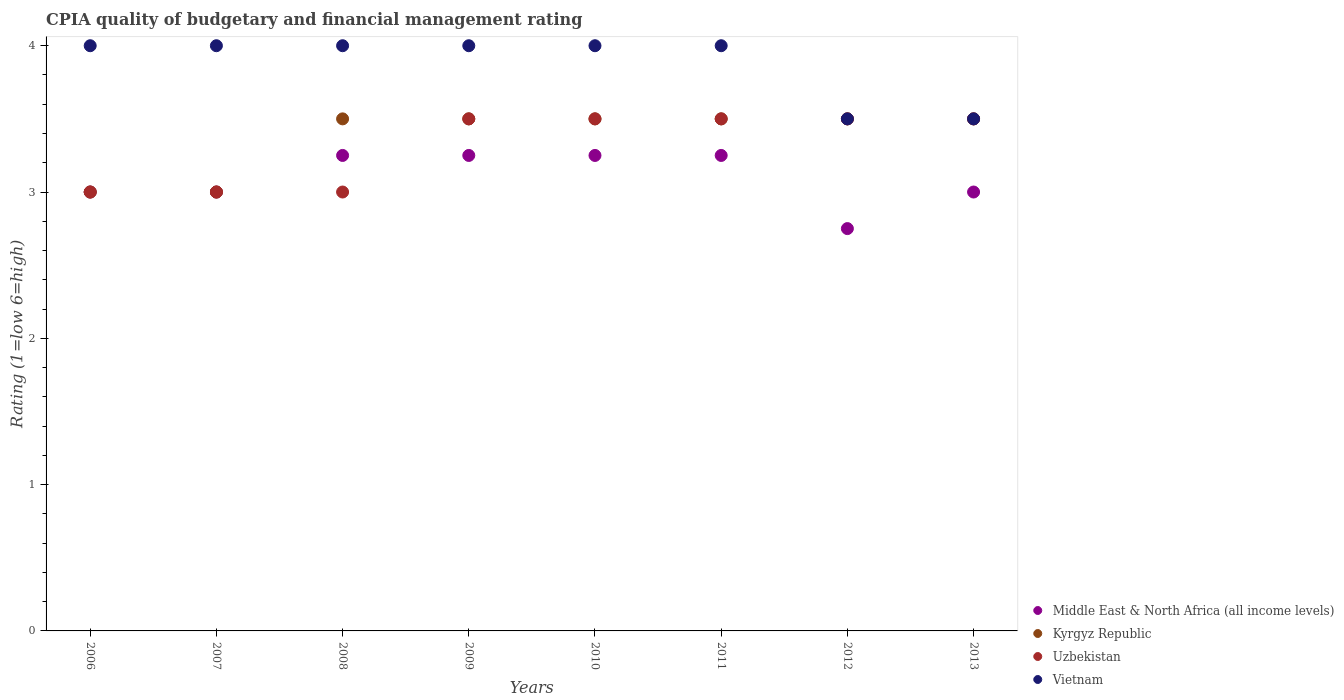How many different coloured dotlines are there?
Offer a very short reply. 4. What is the CPIA rating in Kyrgyz Republic in 2006?
Provide a succinct answer. 3. Across all years, what is the maximum CPIA rating in Middle East & North Africa (all income levels)?
Offer a very short reply. 3.25. In which year was the CPIA rating in Uzbekistan minimum?
Offer a very short reply. 2006. What is the total CPIA rating in Middle East & North Africa (all income levels) in the graph?
Ensure brevity in your answer.  24.75. What is the average CPIA rating in Uzbekistan per year?
Your response must be concise. 3.31. In the year 2008, what is the difference between the CPIA rating in Vietnam and CPIA rating in Kyrgyz Republic?
Ensure brevity in your answer.  0.5. In how many years, is the CPIA rating in Uzbekistan greater than 2.4?
Keep it short and to the point. 8. Is the CPIA rating in Vietnam in 2011 less than that in 2013?
Your answer should be very brief. No. What is the difference between the highest and the second highest CPIA rating in Uzbekistan?
Offer a very short reply. 0. What is the difference between the highest and the lowest CPIA rating in Uzbekistan?
Provide a succinct answer. 0.5. Is it the case that in every year, the sum of the CPIA rating in Kyrgyz Republic and CPIA rating in Uzbekistan  is greater than the CPIA rating in Middle East & North Africa (all income levels)?
Offer a terse response. Yes. Does the CPIA rating in Middle East & North Africa (all income levels) monotonically increase over the years?
Your answer should be very brief. No. How many years are there in the graph?
Offer a terse response. 8. What is the difference between two consecutive major ticks on the Y-axis?
Ensure brevity in your answer.  1. Are the values on the major ticks of Y-axis written in scientific E-notation?
Provide a succinct answer. No. Does the graph contain any zero values?
Your answer should be compact. No. Where does the legend appear in the graph?
Give a very brief answer. Bottom right. What is the title of the graph?
Provide a short and direct response. CPIA quality of budgetary and financial management rating. Does "India" appear as one of the legend labels in the graph?
Offer a terse response. No. What is the label or title of the X-axis?
Offer a terse response. Years. What is the label or title of the Y-axis?
Provide a succinct answer. Rating (1=low 6=high). What is the Rating (1=low 6=high) in Kyrgyz Republic in 2006?
Offer a very short reply. 3. What is the Rating (1=low 6=high) in Uzbekistan in 2006?
Give a very brief answer. 3. What is the Rating (1=low 6=high) of Kyrgyz Republic in 2007?
Your answer should be compact. 3. What is the Rating (1=low 6=high) of Vietnam in 2007?
Provide a short and direct response. 4. What is the Rating (1=low 6=high) of Middle East & North Africa (all income levels) in 2008?
Ensure brevity in your answer.  3.25. What is the Rating (1=low 6=high) in Uzbekistan in 2008?
Offer a very short reply. 3. What is the Rating (1=low 6=high) in Uzbekistan in 2009?
Your answer should be very brief. 3.5. What is the Rating (1=low 6=high) of Middle East & North Africa (all income levels) in 2010?
Offer a terse response. 3.25. What is the Rating (1=low 6=high) in Uzbekistan in 2010?
Ensure brevity in your answer.  3.5. What is the Rating (1=low 6=high) in Middle East & North Africa (all income levels) in 2011?
Your answer should be very brief. 3.25. What is the Rating (1=low 6=high) in Middle East & North Africa (all income levels) in 2012?
Provide a short and direct response. 2.75. What is the Rating (1=low 6=high) in Uzbekistan in 2012?
Your answer should be very brief. 3.5. What is the Rating (1=low 6=high) in Vietnam in 2012?
Your answer should be very brief. 3.5. What is the Rating (1=low 6=high) in Kyrgyz Republic in 2013?
Your answer should be compact. 3.5. What is the Rating (1=low 6=high) in Uzbekistan in 2013?
Keep it short and to the point. 3.5. Across all years, what is the maximum Rating (1=low 6=high) of Middle East & North Africa (all income levels)?
Make the answer very short. 3.25. Across all years, what is the minimum Rating (1=low 6=high) in Middle East & North Africa (all income levels)?
Keep it short and to the point. 2.75. Across all years, what is the minimum Rating (1=low 6=high) of Kyrgyz Republic?
Your answer should be compact. 3. What is the total Rating (1=low 6=high) of Middle East & North Africa (all income levels) in the graph?
Provide a succinct answer. 24.75. What is the total Rating (1=low 6=high) of Uzbekistan in the graph?
Provide a short and direct response. 26.5. What is the difference between the Rating (1=low 6=high) in Middle East & North Africa (all income levels) in 2006 and that in 2007?
Ensure brevity in your answer.  0. What is the difference between the Rating (1=low 6=high) in Kyrgyz Republic in 2006 and that in 2007?
Your response must be concise. 0. What is the difference between the Rating (1=low 6=high) in Uzbekistan in 2006 and that in 2007?
Your answer should be compact. 0. What is the difference between the Rating (1=low 6=high) of Kyrgyz Republic in 2006 and that in 2008?
Offer a very short reply. -0.5. What is the difference between the Rating (1=low 6=high) of Vietnam in 2006 and that in 2008?
Offer a very short reply. 0. What is the difference between the Rating (1=low 6=high) of Uzbekistan in 2006 and that in 2009?
Keep it short and to the point. -0.5. What is the difference between the Rating (1=low 6=high) of Vietnam in 2006 and that in 2009?
Your answer should be compact. 0. What is the difference between the Rating (1=low 6=high) of Middle East & North Africa (all income levels) in 2006 and that in 2010?
Give a very brief answer. -0.25. What is the difference between the Rating (1=low 6=high) of Kyrgyz Republic in 2006 and that in 2010?
Offer a terse response. -0.5. What is the difference between the Rating (1=low 6=high) of Uzbekistan in 2006 and that in 2010?
Offer a very short reply. -0.5. What is the difference between the Rating (1=low 6=high) in Kyrgyz Republic in 2006 and that in 2011?
Keep it short and to the point. -0.5. What is the difference between the Rating (1=low 6=high) in Uzbekistan in 2006 and that in 2011?
Offer a terse response. -0.5. What is the difference between the Rating (1=low 6=high) in Vietnam in 2006 and that in 2011?
Keep it short and to the point. 0. What is the difference between the Rating (1=low 6=high) of Middle East & North Africa (all income levels) in 2006 and that in 2012?
Your answer should be very brief. 0.25. What is the difference between the Rating (1=low 6=high) of Kyrgyz Republic in 2006 and that in 2012?
Your answer should be compact. -0.5. What is the difference between the Rating (1=low 6=high) of Vietnam in 2006 and that in 2012?
Offer a very short reply. 0.5. What is the difference between the Rating (1=low 6=high) in Middle East & North Africa (all income levels) in 2006 and that in 2013?
Ensure brevity in your answer.  0. What is the difference between the Rating (1=low 6=high) in Kyrgyz Republic in 2006 and that in 2013?
Your response must be concise. -0.5. What is the difference between the Rating (1=low 6=high) in Uzbekistan in 2006 and that in 2013?
Offer a very short reply. -0.5. What is the difference between the Rating (1=low 6=high) in Vietnam in 2006 and that in 2013?
Keep it short and to the point. 0.5. What is the difference between the Rating (1=low 6=high) in Middle East & North Africa (all income levels) in 2007 and that in 2008?
Your response must be concise. -0.25. What is the difference between the Rating (1=low 6=high) in Kyrgyz Republic in 2007 and that in 2008?
Offer a terse response. -0.5. What is the difference between the Rating (1=low 6=high) in Middle East & North Africa (all income levels) in 2007 and that in 2009?
Provide a short and direct response. -0.25. What is the difference between the Rating (1=low 6=high) of Kyrgyz Republic in 2007 and that in 2009?
Keep it short and to the point. -0.5. What is the difference between the Rating (1=low 6=high) in Uzbekistan in 2007 and that in 2010?
Provide a short and direct response. -0.5. What is the difference between the Rating (1=low 6=high) of Kyrgyz Republic in 2007 and that in 2011?
Ensure brevity in your answer.  -0.5. What is the difference between the Rating (1=low 6=high) of Vietnam in 2007 and that in 2011?
Offer a very short reply. 0. What is the difference between the Rating (1=low 6=high) in Middle East & North Africa (all income levels) in 2007 and that in 2013?
Your response must be concise. 0. What is the difference between the Rating (1=low 6=high) in Kyrgyz Republic in 2007 and that in 2013?
Your answer should be very brief. -0.5. What is the difference between the Rating (1=low 6=high) in Vietnam in 2007 and that in 2013?
Provide a short and direct response. 0.5. What is the difference between the Rating (1=low 6=high) in Middle East & North Africa (all income levels) in 2008 and that in 2009?
Provide a short and direct response. 0. What is the difference between the Rating (1=low 6=high) of Vietnam in 2008 and that in 2009?
Ensure brevity in your answer.  0. What is the difference between the Rating (1=low 6=high) of Kyrgyz Republic in 2008 and that in 2010?
Offer a very short reply. 0. What is the difference between the Rating (1=low 6=high) of Vietnam in 2008 and that in 2010?
Offer a very short reply. 0. What is the difference between the Rating (1=low 6=high) of Middle East & North Africa (all income levels) in 2008 and that in 2011?
Make the answer very short. 0. What is the difference between the Rating (1=low 6=high) in Kyrgyz Republic in 2008 and that in 2011?
Provide a succinct answer. 0. What is the difference between the Rating (1=low 6=high) in Uzbekistan in 2008 and that in 2011?
Give a very brief answer. -0.5. What is the difference between the Rating (1=low 6=high) in Kyrgyz Republic in 2008 and that in 2012?
Keep it short and to the point. 0. What is the difference between the Rating (1=low 6=high) in Kyrgyz Republic in 2008 and that in 2013?
Offer a terse response. 0. What is the difference between the Rating (1=low 6=high) in Kyrgyz Republic in 2009 and that in 2010?
Make the answer very short. 0. What is the difference between the Rating (1=low 6=high) in Vietnam in 2009 and that in 2010?
Ensure brevity in your answer.  0. What is the difference between the Rating (1=low 6=high) in Kyrgyz Republic in 2009 and that in 2011?
Give a very brief answer. 0. What is the difference between the Rating (1=low 6=high) of Kyrgyz Republic in 2009 and that in 2012?
Provide a succinct answer. 0. What is the difference between the Rating (1=low 6=high) in Uzbekistan in 2009 and that in 2012?
Keep it short and to the point. 0. What is the difference between the Rating (1=low 6=high) in Middle East & North Africa (all income levels) in 2009 and that in 2013?
Offer a terse response. 0.25. What is the difference between the Rating (1=low 6=high) of Uzbekistan in 2010 and that in 2011?
Offer a very short reply. 0. What is the difference between the Rating (1=low 6=high) in Vietnam in 2010 and that in 2011?
Ensure brevity in your answer.  0. What is the difference between the Rating (1=low 6=high) of Middle East & North Africa (all income levels) in 2010 and that in 2012?
Provide a short and direct response. 0.5. What is the difference between the Rating (1=low 6=high) in Kyrgyz Republic in 2010 and that in 2012?
Give a very brief answer. 0. What is the difference between the Rating (1=low 6=high) of Uzbekistan in 2010 and that in 2012?
Give a very brief answer. 0. What is the difference between the Rating (1=low 6=high) in Vietnam in 2010 and that in 2012?
Offer a very short reply. 0.5. What is the difference between the Rating (1=low 6=high) in Kyrgyz Republic in 2010 and that in 2013?
Your answer should be compact. 0. What is the difference between the Rating (1=low 6=high) in Middle East & North Africa (all income levels) in 2011 and that in 2012?
Offer a terse response. 0.5. What is the difference between the Rating (1=low 6=high) in Uzbekistan in 2011 and that in 2012?
Provide a short and direct response. 0. What is the difference between the Rating (1=low 6=high) in Vietnam in 2011 and that in 2012?
Your answer should be very brief. 0.5. What is the difference between the Rating (1=low 6=high) of Middle East & North Africa (all income levels) in 2011 and that in 2013?
Keep it short and to the point. 0.25. What is the difference between the Rating (1=low 6=high) of Kyrgyz Republic in 2011 and that in 2013?
Make the answer very short. 0. What is the difference between the Rating (1=low 6=high) in Kyrgyz Republic in 2012 and that in 2013?
Your response must be concise. 0. What is the difference between the Rating (1=low 6=high) of Middle East & North Africa (all income levels) in 2006 and the Rating (1=low 6=high) of Kyrgyz Republic in 2007?
Your answer should be compact. 0. What is the difference between the Rating (1=low 6=high) of Kyrgyz Republic in 2006 and the Rating (1=low 6=high) of Uzbekistan in 2007?
Offer a terse response. 0. What is the difference between the Rating (1=low 6=high) in Middle East & North Africa (all income levels) in 2006 and the Rating (1=low 6=high) in Kyrgyz Republic in 2008?
Offer a terse response. -0.5. What is the difference between the Rating (1=low 6=high) of Kyrgyz Republic in 2006 and the Rating (1=low 6=high) of Vietnam in 2008?
Keep it short and to the point. -1. What is the difference between the Rating (1=low 6=high) of Middle East & North Africa (all income levels) in 2006 and the Rating (1=low 6=high) of Uzbekistan in 2009?
Offer a very short reply. -0.5. What is the difference between the Rating (1=low 6=high) of Middle East & North Africa (all income levels) in 2006 and the Rating (1=low 6=high) of Vietnam in 2009?
Provide a short and direct response. -1. What is the difference between the Rating (1=low 6=high) in Kyrgyz Republic in 2006 and the Rating (1=low 6=high) in Uzbekistan in 2009?
Provide a succinct answer. -0.5. What is the difference between the Rating (1=low 6=high) of Middle East & North Africa (all income levels) in 2006 and the Rating (1=low 6=high) of Kyrgyz Republic in 2010?
Give a very brief answer. -0.5. What is the difference between the Rating (1=low 6=high) of Middle East & North Africa (all income levels) in 2006 and the Rating (1=low 6=high) of Vietnam in 2010?
Your response must be concise. -1. What is the difference between the Rating (1=low 6=high) in Kyrgyz Republic in 2006 and the Rating (1=low 6=high) in Vietnam in 2010?
Provide a succinct answer. -1. What is the difference between the Rating (1=low 6=high) of Middle East & North Africa (all income levels) in 2006 and the Rating (1=low 6=high) of Kyrgyz Republic in 2011?
Offer a terse response. -0.5. What is the difference between the Rating (1=low 6=high) of Middle East & North Africa (all income levels) in 2006 and the Rating (1=low 6=high) of Uzbekistan in 2011?
Your answer should be compact. -0.5. What is the difference between the Rating (1=low 6=high) in Kyrgyz Republic in 2006 and the Rating (1=low 6=high) in Uzbekistan in 2011?
Your answer should be compact. -0.5. What is the difference between the Rating (1=low 6=high) in Kyrgyz Republic in 2006 and the Rating (1=low 6=high) in Vietnam in 2011?
Provide a succinct answer. -1. What is the difference between the Rating (1=low 6=high) in Middle East & North Africa (all income levels) in 2006 and the Rating (1=low 6=high) in Kyrgyz Republic in 2012?
Offer a terse response. -0.5. What is the difference between the Rating (1=low 6=high) in Middle East & North Africa (all income levels) in 2006 and the Rating (1=low 6=high) in Vietnam in 2012?
Ensure brevity in your answer.  -0.5. What is the difference between the Rating (1=low 6=high) of Middle East & North Africa (all income levels) in 2006 and the Rating (1=low 6=high) of Uzbekistan in 2013?
Give a very brief answer. -0.5. What is the difference between the Rating (1=low 6=high) of Middle East & North Africa (all income levels) in 2006 and the Rating (1=low 6=high) of Vietnam in 2013?
Your answer should be compact. -0.5. What is the difference between the Rating (1=low 6=high) of Kyrgyz Republic in 2006 and the Rating (1=low 6=high) of Vietnam in 2013?
Your response must be concise. -0.5. What is the difference between the Rating (1=low 6=high) in Middle East & North Africa (all income levels) in 2007 and the Rating (1=low 6=high) in Kyrgyz Republic in 2008?
Your answer should be very brief. -0.5. What is the difference between the Rating (1=low 6=high) in Middle East & North Africa (all income levels) in 2007 and the Rating (1=low 6=high) in Uzbekistan in 2008?
Make the answer very short. 0. What is the difference between the Rating (1=low 6=high) of Middle East & North Africa (all income levels) in 2007 and the Rating (1=low 6=high) of Kyrgyz Republic in 2009?
Offer a very short reply. -0.5. What is the difference between the Rating (1=low 6=high) in Middle East & North Africa (all income levels) in 2007 and the Rating (1=low 6=high) in Uzbekistan in 2009?
Give a very brief answer. -0.5. What is the difference between the Rating (1=low 6=high) in Middle East & North Africa (all income levels) in 2007 and the Rating (1=low 6=high) in Vietnam in 2010?
Your answer should be very brief. -1. What is the difference between the Rating (1=low 6=high) of Kyrgyz Republic in 2007 and the Rating (1=low 6=high) of Uzbekistan in 2010?
Give a very brief answer. -0.5. What is the difference between the Rating (1=low 6=high) in Middle East & North Africa (all income levels) in 2007 and the Rating (1=low 6=high) in Kyrgyz Republic in 2011?
Make the answer very short. -0.5. What is the difference between the Rating (1=low 6=high) of Middle East & North Africa (all income levels) in 2007 and the Rating (1=low 6=high) of Uzbekistan in 2012?
Your response must be concise. -0.5. What is the difference between the Rating (1=low 6=high) of Uzbekistan in 2007 and the Rating (1=low 6=high) of Vietnam in 2012?
Provide a short and direct response. -0.5. What is the difference between the Rating (1=low 6=high) of Middle East & North Africa (all income levels) in 2007 and the Rating (1=low 6=high) of Kyrgyz Republic in 2013?
Make the answer very short. -0.5. What is the difference between the Rating (1=low 6=high) of Middle East & North Africa (all income levels) in 2007 and the Rating (1=low 6=high) of Uzbekistan in 2013?
Ensure brevity in your answer.  -0.5. What is the difference between the Rating (1=low 6=high) of Kyrgyz Republic in 2007 and the Rating (1=low 6=high) of Uzbekistan in 2013?
Give a very brief answer. -0.5. What is the difference between the Rating (1=low 6=high) in Uzbekistan in 2007 and the Rating (1=low 6=high) in Vietnam in 2013?
Offer a very short reply. -0.5. What is the difference between the Rating (1=low 6=high) of Middle East & North Africa (all income levels) in 2008 and the Rating (1=low 6=high) of Kyrgyz Republic in 2009?
Make the answer very short. -0.25. What is the difference between the Rating (1=low 6=high) in Middle East & North Africa (all income levels) in 2008 and the Rating (1=low 6=high) in Uzbekistan in 2009?
Your response must be concise. -0.25. What is the difference between the Rating (1=low 6=high) in Middle East & North Africa (all income levels) in 2008 and the Rating (1=low 6=high) in Vietnam in 2009?
Make the answer very short. -0.75. What is the difference between the Rating (1=low 6=high) in Kyrgyz Republic in 2008 and the Rating (1=low 6=high) in Uzbekistan in 2009?
Make the answer very short. 0. What is the difference between the Rating (1=low 6=high) in Kyrgyz Republic in 2008 and the Rating (1=low 6=high) in Vietnam in 2009?
Your answer should be compact. -0.5. What is the difference between the Rating (1=low 6=high) of Uzbekistan in 2008 and the Rating (1=low 6=high) of Vietnam in 2009?
Provide a succinct answer. -1. What is the difference between the Rating (1=low 6=high) of Middle East & North Africa (all income levels) in 2008 and the Rating (1=low 6=high) of Kyrgyz Republic in 2010?
Provide a succinct answer. -0.25. What is the difference between the Rating (1=low 6=high) of Middle East & North Africa (all income levels) in 2008 and the Rating (1=low 6=high) of Uzbekistan in 2010?
Your answer should be very brief. -0.25. What is the difference between the Rating (1=low 6=high) in Middle East & North Africa (all income levels) in 2008 and the Rating (1=low 6=high) in Vietnam in 2010?
Give a very brief answer. -0.75. What is the difference between the Rating (1=low 6=high) of Kyrgyz Republic in 2008 and the Rating (1=low 6=high) of Vietnam in 2010?
Offer a very short reply. -0.5. What is the difference between the Rating (1=low 6=high) of Middle East & North Africa (all income levels) in 2008 and the Rating (1=low 6=high) of Uzbekistan in 2011?
Make the answer very short. -0.25. What is the difference between the Rating (1=low 6=high) in Middle East & North Africa (all income levels) in 2008 and the Rating (1=low 6=high) in Vietnam in 2011?
Offer a terse response. -0.75. What is the difference between the Rating (1=low 6=high) of Kyrgyz Republic in 2008 and the Rating (1=low 6=high) of Uzbekistan in 2011?
Keep it short and to the point. 0. What is the difference between the Rating (1=low 6=high) in Uzbekistan in 2008 and the Rating (1=low 6=high) in Vietnam in 2011?
Make the answer very short. -1. What is the difference between the Rating (1=low 6=high) of Middle East & North Africa (all income levels) in 2008 and the Rating (1=low 6=high) of Vietnam in 2012?
Make the answer very short. -0.25. What is the difference between the Rating (1=low 6=high) of Kyrgyz Republic in 2008 and the Rating (1=low 6=high) of Uzbekistan in 2012?
Make the answer very short. 0. What is the difference between the Rating (1=low 6=high) in Kyrgyz Republic in 2008 and the Rating (1=low 6=high) in Vietnam in 2012?
Make the answer very short. 0. What is the difference between the Rating (1=low 6=high) in Middle East & North Africa (all income levels) in 2008 and the Rating (1=low 6=high) in Uzbekistan in 2013?
Your answer should be compact. -0.25. What is the difference between the Rating (1=low 6=high) in Middle East & North Africa (all income levels) in 2008 and the Rating (1=low 6=high) in Vietnam in 2013?
Ensure brevity in your answer.  -0.25. What is the difference between the Rating (1=low 6=high) in Kyrgyz Republic in 2008 and the Rating (1=low 6=high) in Uzbekistan in 2013?
Keep it short and to the point. 0. What is the difference between the Rating (1=low 6=high) in Kyrgyz Republic in 2008 and the Rating (1=low 6=high) in Vietnam in 2013?
Offer a terse response. 0. What is the difference between the Rating (1=low 6=high) in Uzbekistan in 2008 and the Rating (1=low 6=high) in Vietnam in 2013?
Your response must be concise. -0.5. What is the difference between the Rating (1=low 6=high) of Middle East & North Africa (all income levels) in 2009 and the Rating (1=low 6=high) of Kyrgyz Republic in 2010?
Offer a terse response. -0.25. What is the difference between the Rating (1=low 6=high) of Middle East & North Africa (all income levels) in 2009 and the Rating (1=low 6=high) of Vietnam in 2010?
Give a very brief answer. -0.75. What is the difference between the Rating (1=low 6=high) in Kyrgyz Republic in 2009 and the Rating (1=low 6=high) in Vietnam in 2010?
Offer a very short reply. -0.5. What is the difference between the Rating (1=low 6=high) in Uzbekistan in 2009 and the Rating (1=low 6=high) in Vietnam in 2010?
Your answer should be very brief. -0.5. What is the difference between the Rating (1=low 6=high) in Middle East & North Africa (all income levels) in 2009 and the Rating (1=low 6=high) in Vietnam in 2011?
Your answer should be very brief. -0.75. What is the difference between the Rating (1=low 6=high) in Kyrgyz Republic in 2009 and the Rating (1=low 6=high) in Vietnam in 2011?
Your answer should be very brief. -0.5. What is the difference between the Rating (1=low 6=high) of Uzbekistan in 2009 and the Rating (1=low 6=high) of Vietnam in 2011?
Your answer should be very brief. -0.5. What is the difference between the Rating (1=low 6=high) of Middle East & North Africa (all income levels) in 2009 and the Rating (1=low 6=high) of Uzbekistan in 2012?
Make the answer very short. -0.25. What is the difference between the Rating (1=low 6=high) of Middle East & North Africa (all income levels) in 2009 and the Rating (1=low 6=high) of Vietnam in 2012?
Your response must be concise. -0.25. What is the difference between the Rating (1=low 6=high) of Kyrgyz Republic in 2009 and the Rating (1=low 6=high) of Uzbekistan in 2012?
Provide a succinct answer. 0. What is the difference between the Rating (1=low 6=high) in Kyrgyz Republic in 2009 and the Rating (1=low 6=high) in Vietnam in 2012?
Provide a short and direct response. 0. What is the difference between the Rating (1=low 6=high) in Middle East & North Africa (all income levels) in 2009 and the Rating (1=low 6=high) in Kyrgyz Republic in 2013?
Offer a very short reply. -0.25. What is the difference between the Rating (1=low 6=high) in Middle East & North Africa (all income levels) in 2009 and the Rating (1=low 6=high) in Vietnam in 2013?
Your answer should be very brief. -0.25. What is the difference between the Rating (1=low 6=high) in Kyrgyz Republic in 2009 and the Rating (1=low 6=high) in Vietnam in 2013?
Keep it short and to the point. 0. What is the difference between the Rating (1=low 6=high) in Middle East & North Africa (all income levels) in 2010 and the Rating (1=low 6=high) in Uzbekistan in 2011?
Give a very brief answer. -0.25. What is the difference between the Rating (1=low 6=high) in Middle East & North Africa (all income levels) in 2010 and the Rating (1=low 6=high) in Vietnam in 2011?
Make the answer very short. -0.75. What is the difference between the Rating (1=low 6=high) in Kyrgyz Republic in 2010 and the Rating (1=low 6=high) in Uzbekistan in 2011?
Provide a short and direct response. 0. What is the difference between the Rating (1=low 6=high) in Middle East & North Africa (all income levels) in 2010 and the Rating (1=low 6=high) in Uzbekistan in 2012?
Give a very brief answer. -0.25. What is the difference between the Rating (1=low 6=high) of Kyrgyz Republic in 2010 and the Rating (1=low 6=high) of Uzbekistan in 2012?
Ensure brevity in your answer.  0. What is the difference between the Rating (1=low 6=high) in Kyrgyz Republic in 2010 and the Rating (1=low 6=high) in Vietnam in 2012?
Keep it short and to the point. 0. What is the difference between the Rating (1=low 6=high) of Middle East & North Africa (all income levels) in 2010 and the Rating (1=low 6=high) of Kyrgyz Republic in 2013?
Offer a very short reply. -0.25. What is the difference between the Rating (1=low 6=high) in Middle East & North Africa (all income levels) in 2010 and the Rating (1=low 6=high) in Vietnam in 2013?
Ensure brevity in your answer.  -0.25. What is the difference between the Rating (1=low 6=high) in Kyrgyz Republic in 2010 and the Rating (1=low 6=high) in Uzbekistan in 2013?
Provide a succinct answer. 0. What is the difference between the Rating (1=low 6=high) in Uzbekistan in 2010 and the Rating (1=low 6=high) in Vietnam in 2013?
Your response must be concise. 0. What is the difference between the Rating (1=low 6=high) of Middle East & North Africa (all income levels) in 2011 and the Rating (1=low 6=high) of Kyrgyz Republic in 2012?
Offer a terse response. -0.25. What is the difference between the Rating (1=low 6=high) in Middle East & North Africa (all income levels) in 2011 and the Rating (1=low 6=high) in Uzbekistan in 2012?
Keep it short and to the point. -0.25. What is the difference between the Rating (1=low 6=high) in Middle East & North Africa (all income levels) in 2011 and the Rating (1=low 6=high) in Vietnam in 2012?
Make the answer very short. -0.25. What is the difference between the Rating (1=low 6=high) in Kyrgyz Republic in 2011 and the Rating (1=low 6=high) in Uzbekistan in 2012?
Keep it short and to the point. 0. What is the difference between the Rating (1=low 6=high) in Middle East & North Africa (all income levels) in 2011 and the Rating (1=low 6=high) in Vietnam in 2013?
Your answer should be very brief. -0.25. What is the difference between the Rating (1=low 6=high) in Kyrgyz Republic in 2011 and the Rating (1=low 6=high) in Uzbekistan in 2013?
Offer a very short reply. 0. What is the difference between the Rating (1=low 6=high) in Uzbekistan in 2011 and the Rating (1=low 6=high) in Vietnam in 2013?
Ensure brevity in your answer.  0. What is the difference between the Rating (1=low 6=high) in Middle East & North Africa (all income levels) in 2012 and the Rating (1=low 6=high) in Kyrgyz Republic in 2013?
Your response must be concise. -0.75. What is the difference between the Rating (1=low 6=high) in Middle East & North Africa (all income levels) in 2012 and the Rating (1=low 6=high) in Uzbekistan in 2013?
Your answer should be very brief. -0.75. What is the difference between the Rating (1=low 6=high) in Middle East & North Africa (all income levels) in 2012 and the Rating (1=low 6=high) in Vietnam in 2013?
Offer a terse response. -0.75. What is the difference between the Rating (1=low 6=high) of Kyrgyz Republic in 2012 and the Rating (1=low 6=high) of Uzbekistan in 2013?
Offer a very short reply. 0. What is the difference between the Rating (1=low 6=high) in Kyrgyz Republic in 2012 and the Rating (1=low 6=high) in Vietnam in 2013?
Keep it short and to the point. 0. What is the average Rating (1=low 6=high) in Middle East & North Africa (all income levels) per year?
Keep it short and to the point. 3.09. What is the average Rating (1=low 6=high) in Kyrgyz Republic per year?
Provide a succinct answer. 3.38. What is the average Rating (1=low 6=high) of Uzbekistan per year?
Offer a terse response. 3.31. What is the average Rating (1=low 6=high) in Vietnam per year?
Ensure brevity in your answer.  3.88. In the year 2006, what is the difference between the Rating (1=low 6=high) in Middle East & North Africa (all income levels) and Rating (1=low 6=high) in Kyrgyz Republic?
Offer a very short reply. 0. In the year 2007, what is the difference between the Rating (1=low 6=high) in Middle East & North Africa (all income levels) and Rating (1=low 6=high) in Uzbekistan?
Your response must be concise. 0. In the year 2007, what is the difference between the Rating (1=low 6=high) in Middle East & North Africa (all income levels) and Rating (1=low 6=high) in Vietnam?
Ensure brevity in your answer.  -1. In the year 2007, what is the difference between the Rating (1=low 6=high) of Kyrgyz Republic and Rating (1=low 6=high) of Uzbekistan?
Offer a terse response. 0. In the year 2007, what is the difference between the Rating (1=low 6=high) in Kyrgyz Republic and Rating (1=low 6=high) in Vietnam?
Ensure brevity in your answer.  -1. In the year 2008, what is the difference between the Rating (1=low 6=high) in Middle East & North Africa (all income levels) and Rating (1=low 6=high) in Kyrgyz Republic?
Offer a very short reply. -0.25. In the year 2008, what is the difference between the Rating (1=low 6=high) in Middle East & North Africa (all income levels) and Rating (1=low 6=high) in Uzbekistan?
Ensure brevity in your answer.  0.25. In the year 2008, what is the difference between the Rating (1=low 6=high) in Middle East & North Africa (all income levels) and Rating (1=low 6=high) in Vietnam?
Keep it short and to the point. -0.75. In the year 2008, what is the difference between the Rating (1=low 6=high) in Kyrgyz Republic and Rating (1=low 6=high) in Uzbekistan?
Your response must be concise. 0.5. In the year 2009, what is the difference between the Rating (1=low 6=high) in Middle East & North Africa (all income levels) and Rating (1=low 6=high) in Vietnam?
Provide a succinct answer. -0.75. In the year 2009, what is the difference between the Rating (1=low 6=high) in Kyrgyz Republic and Rating (1=low 6=high) in Uzbekistan?
Keep it short and to the point. 0. In the year 2009, what is the difference between the Rating (1=low 6=high) of Kyrgyz Republic and Rating (1=low 6=high) of Vietnam?
Give a very brief answer. -0.5. In the year 2009, what is the difference between the Rating (1=low 6=high) in Uzbekistan and Rating (1=low 6=high) in Vietnam?
Keep it short and to the point. -0.5. In the year 2010, what is the difference between the Rating (1=low 6=high) in Middle East & North Africa (all income levels) and Rating (1=low 6=high) in Vietnam?
Offer a very short reply. -0.75. In the year 2010, what is the difference between the Rating (1=low 6=high) in Uzbekistan and Rating (1=low 6=high) in Vietnam?
Give a very brief answer. -0.5. In the year 2011, what is the difference between the Rating (1=low 6=high) in Middle East & North Africa (all income levels) and Rating (1=low 6=high) in Vietnam?
Ensure brevity in your answer.  -0.75. In the year 2011, what is the difference between the Rating (1=low 6=high) of Uzbekistan and Rating (1=low 6=high) of Vietnam?
Your answer should be compact. -0.5. In the year 2012, what is the difference between the Rating (1=low 6=high) in Middle East & North Africa (all income levels) and Rating (1=low 6=high) in Kyrgyz Republic?
Give a very brief answer. -0.75. In the year 2012, what is the difference between the Rating (1=low 6=high) of Middle East & North Africa (all income levels) and Rating (1=low 6=high) of Uzbekistan?
Give a very brief answer. -0.75. In the year 2012, what is the difference between the Rating (1=low 6=high) in Middle East & North Africa (all income levels) and Rating (1=low 6=high) in Vietnam?
Your answer should be compact. -0.75. In the year 2013, what is the difference between the Rating (1=low 6=high) of Middle East & North Africa (all income levels) and Rating (1=low 6=high) of Kyrgyz Republic?
Your response must be concise. -0.5. In the year 2013, what is the difference between the Rating (1=low 6=high) in Kyrgyz Republic and Rating (1=low 6=high) in Uzbekistan?
Your response must be concise. 0. In the year 2013, what is the difference between the Rating (1=low 6=high) in Kyrgyz Republic and Rating (1=low 6=high) in Vietnam?
Your answer should be compact. 0. What is the ratio of the Rating (1=low 6=high) of Vietnam in 2006 to that in 2007?
Provide a succinct answer. 1. What is the ratio of the Rating (1=low 6=high) in Middle East & North Africa (all income levels) in 2006 to that in 2008?
Provide a short and direct response. 0.92. What is the ratio of the Rating (1=low 6=high) in Kyrgyz Republic in 2006 to that in 2008?
Keep it short and to the point. 0.86. What is the ratio of the Rating (1=low 6=high) of Uzbekistan in 2006 to that in 2009?
Ensure brevity in your answer.  0.86. What is the ratio of the Rating (1=low 6=high) in Middle East & North Africa (all income levels) in 2006 to that in 2010?
Offer a terse response. 0.92. What is the ratio of the Rating (1=low 6=high) of Kyrgyz Republic in 2006 to that in 2011?
Keep it short and to the point. 0.86. What is the ratio of the Rating (1=low 6=high) of Uzbekistan in 2006 to that in 2011?
Keep it short and to the point. 0.86. What is the ratio of the Rating (1=low 6=high) in Vietnam in 2006 to that in 2011?
Provide a short and direct response. 1. What is the ratio of the Rating (1=low 6=high) in Kyrgyz Republic in 2006 to that in 2012?
Give a very brief answer. 0.86. What is the ratio of the Rating (1=low 6=high) of Uzbekistan in 2006 to that in 2012?
Make the answer very short. 0.86. What is the ratio of the Rating (1=low 6=high) of Middle East & North Africa (all income levels) in 2006 to that in 2013?
Keep it short and to the point. 1. What is the ratio of the Rating (1=low 6=high) of Kyrgyz Republic in 2006 to that in 2013?
Your answer should be very brief. 0.86. What is the ratio of the Rating (1=low 6=high) of Uzbekistan in 2006 to that in 2013?
Ensure brevity in your answer.  0.86. What is the ratio of the Rating (1=low 6=high) in Vietnam in 2006 to that in 2013?
Your response must be concise. 1.14. What is the ratio of the Rating (1=low 6=high) of Middle East & North Africa (all income levels) in 2007 to that in 2008?
Your response must be concise. 0.92. What is the ratio of the Rating (1=low 6=high) of Uzbekistan in 2007 to that in 2008?
Keep it short and to the point. 1. What is the ratio of the Rating (1=low 6=high) of Vietnam in 2007 to that in 2008?
Provide a succinct answer. 1. What is the ratio of the Rating (1=low 6=high) of Kyrgyz Republic in 2007 to that in 2009?
Make the answer very short. 0.86. What is the ratio of the Rating (1=low 6=high) in Middle East & North Africa (all income levels) in 2007 to that in 2010?
Ensure brevity in your answer.  0.92. What is the ratio of the Rating (1=low 6=high) in Uzbekistan in 2007 to that in 2010?
Provide a short and direct response. 0.86. What is the ratio of the Rating (1=low 6=high) of Vietnam in 2007 to that in 2010?
Offer a very short reply. 1. What is the ratio of the Rating (1=low 6=high) in Vietnam in 2007 to that in 2011?
Give a very brief answer. 1. What is the ratio of the Rating (1=low 6=high) of Middle East & North Africa (all income levels) in 2007 to that in 2012?
Offer a terse response. 1.09. What is the ratio of the Rating (1=low 6=high) of Kyrgyz Republic in 2007 to that in 2012?
Your answer should be compact. 0.86. What is the ratio of the Rating (1=low 6=high) of Vietnam in 2007 to that in 2012?
Provide a succinct answer. 1.14. What is the ratio of the Rating (1=low 6=high) of Middle East & North Africa (all income levels) in 2007 to that in 2013?
Your answer should be very brief. 1. What is the ratio of the Rating (1=low 6=high) of Kyrgyz Republic in 2007 to that in 2013?
Offer a very short reply. 0.86. What is the ratio of the Rating (1=low 6=high) in Kyrgyz Republic in 2008 to that in 2009?
Offer a very short reply. 1. What is the ratio of the Rating (1=low 6=high) in Middle East & North Africa (all income levels) in 2008 to that in 2010?
Offer a terse response. 1. What is the ratio of the Rating (1=low 6=high) in Kyrgyz Republic in 2008 to that in 2011?
Ensure brevity in your answer.  1. What is the ratio of the Rating (1=low 6=high) of Uzbekistan in 2008 to that in 2011?
Offer a very short reply. 0.86. What is the ratio of the Rating (1=low 6=high) of Vietnam in 2008 to that in 2011?
Your response must be concise. 1. What is the ratio of the Rating (1=low 6=high) of Middle East & North Africa (all income levels) in 2008 to that in 2012?
Keep it short and to the point. 1.18. What is the ratio of the Rating (1=low 6=high) in Kyrgyz Republic in 2008 to that in 2012?
Your answer should be very brief. 1. What is the ratio of the Rating (1=low 6=high) in Uzbekistan in 2008 to that in 2012?
Your answer should be compact. 0.86. What is the ratio of the Rating (1=low 6=high) in Middle East & North Africa (all income levels) in 2008 to that in 2013?
Make the answer very short. 1.08. What is the ratio of the Rating (1=low 6=high) of Kyrgyz Republic in 2008 to that in 2013?
Keep it short and to the point. 1. What is the ratio of the Rating (1=low 6=high) in Vietnam in 2008 to that in 2013?
Offer a very short reply. 1.14. What is the ratio of the Rating (1=low 6=high) in Kyrgyz Republic in 2009 to that in 2010?
Your response must be concise. 1. What is the ratio of the Rating (1=low 6=high) in Middle East & North Africa (all income levels) in 2009 to that in 2011?
Offer a very short reply. 1. What is the ratio of the Rating (1=low 6=high) in Kyrgyz Republic in 2009 to that in 2011?
Your answer should be very brief. 1. What is the ratio of the Rating (1=low 6=high) of Uzbekistan in 2009 to that in 2011?
Provide a short and direct response. 1. What is the ratio of the Rating (1=low 6=high) of Vietnam in 2009 to that in 2011?
Offer a terse response. 1. What is the ratio of the Rating (1=low 6=high) of Middle East & North Africa (all income levels) in 2009 to that in 2012?
Provide a succinct answer. 1.18. What is the ratio of the Rating (1=low 6=high) of Kyrgyz Republic in 2009 to that in 2012?
Your answer should be compact. 1. What is the ratio of the Rating (1=low 6=high) in Vietnam in 2009 to that in 2012?
Your response must be concise. 1.14. What is the ratio of the Rating (1=low 6=high) of Vietnam in 2009 to that in 2013?
Keep it short and to the point. 1.14. What is the ratio of the Rating (1=low 6=high) in Middle East & North Africa (all income levels) in 2010 to that in 2011?
Keep it short and to the point. 1. What is the ratio of the Rating (1=low 6=high) in Kyrgyz Republic in 2010 to that in 2011?
Provide a succinct answer. 1. What is the ratio of the Rating (1=low 6=high) in Uzbekistan in 2010 to that in 2011?
Make the answer very short. 1. What is the ratio of the Rating (1=low 6=high) of Middle East & North Africa (all income levels) in 2010 to that in 2012?
Keep it short and to the point. 1.18. What is the ratio of the Rating (1=low 6=high) in Uzbekistan in 2010 to that in 2012?
Provide a short and direct response. 1. What is the ratio of the Rating (1=low 6=high) of Middle East & North Africa (all income levels) in 2011 to that in 2012?
Provide a short and direct response. 1.18. What is the ratio of the Rating (1=low 6=high) in Kyrgyz Republic in 2011 to that in 2012?
Give a very brief answer. 1. What is the ratio of the Rating (1=low 6=high) in Uzbekistan in 2011 to that in 2013?
Your answer should be very brief. 1. What is the difference between the highest and the second highest Rating (1=low 6=high) of Uzbekistan?
Provide a short and direct response. 0. 